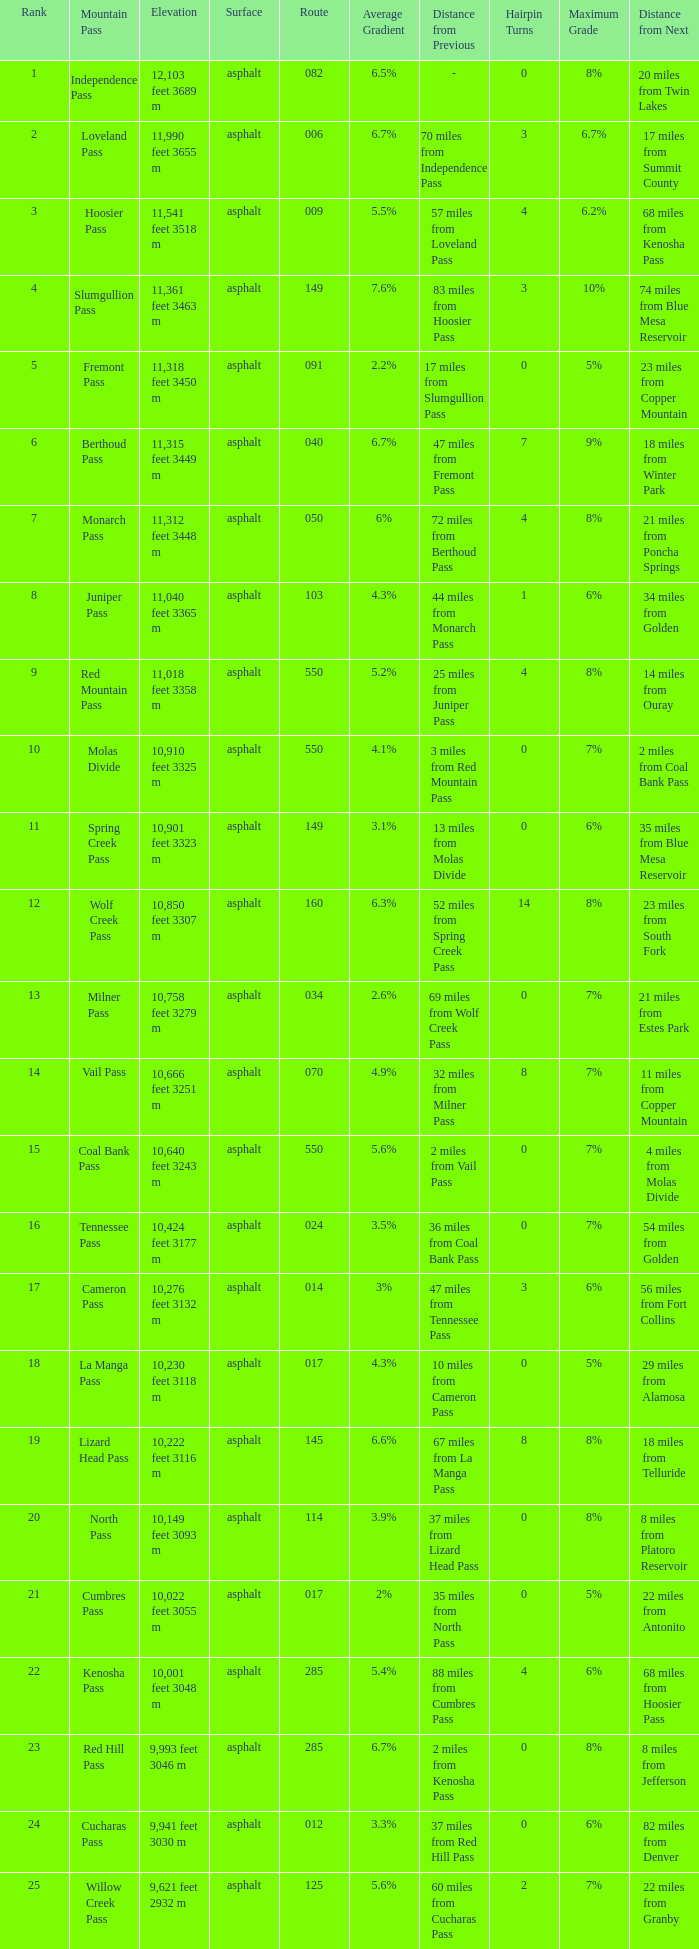What Mountain Pass has an Elevation of 10,001 feet 3048 m? Kenosha Pass. 